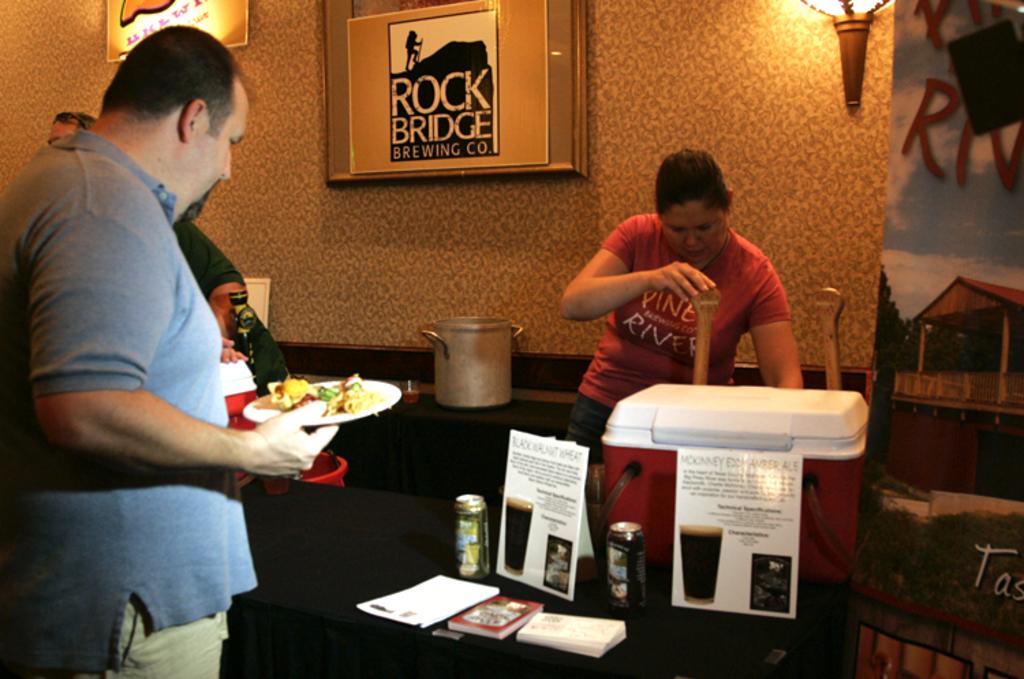What is the frame on the wall?
Offer a terse response. Rock bridge brewing co. What does the red shirt say?
Ensure brevity in your answer.  Pine river. 